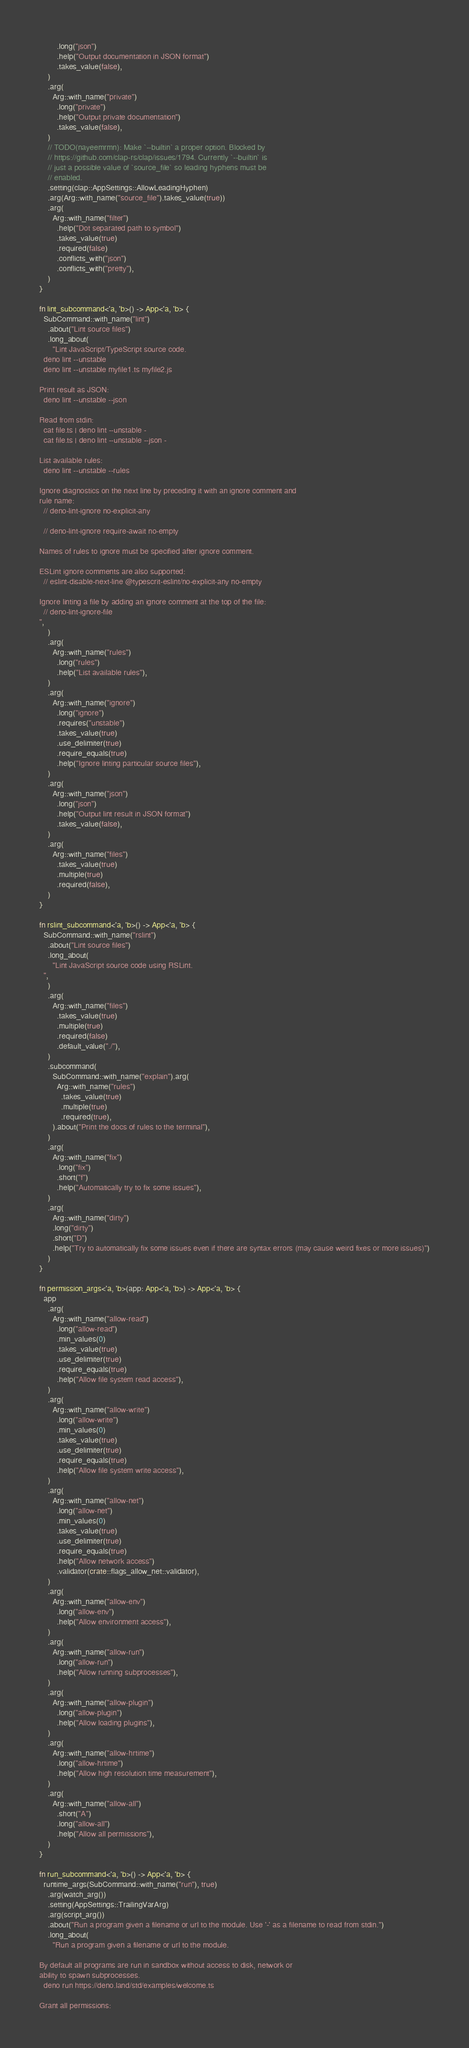<code> <loc_0><loc_0><loc_500><loc_500><_Rust_>        .long("json")
        .help("Output documentation in JSON format")
        .takes_value(false),
    )
    .arg(
      Arg::with_name("private")
        .long("private")
        .help("Output private documentation")
        .takes_value(false),
    )
    // TODO(nayeemrmn): Make `--builtin` a proper option. Blocked by
    // https://github.com/clap-rs/clap/issues/1794. Currently `--builtin` is
    // just a possible value of `source_file` so leading hyphens must be
    // enabled.
    .setting(clap::AppSettings::AllowLeadingHyphen)
    .arg(Arg::with_name("source_file").takes_value(true))
    .arg(
      Arg::with_name("filter")
        .help("Dot separated path to symbol")
        .takes_value(true)
        .required(false)
        .conflicts_with("json")
        .conflicts_with("pretty"),
    )
}

fn lint_subcommand<'a, 'b>() -> App<'a, 'b> {
  SubCommand::with_name("lint")
    .about("Lint source files")
    .long_about(
      "Lint JavaScript/TypeScript source code.
  deno lint --unstable
  deno lint --unstable myfile1.ts myfile2.js

Print result as JSON:
  deno lint --unstable --json

Read from stdin:
  cat file.ts | deno lint --unstable -
  cat file.ts | deno lint --unstable --json -

List available rules:
  deno lint --unstable --rules

Ignore diagnostics on the next line by preceding it with an ignore comment and
rule name:
  // deno-lint-ignore no-explicit-any

  // deno-lint-ignore require-await no-empty

Names of rules to ignore must be specified after ignore comment.

ESLint ignore comments are also supported:
  // eslint-disable-next-line @typescrit-eslint/no-explicit-any no-empty

Ignore linting a file by adding an ignore comment at the top of the file:
  // deno-lint-ignore-file
",
    )
    .arg(
      Arg::with_name("rules")
        .long("rules")
        .help("List available rules"),
    )
    .arg(
      Arg::with_name("ignore")
        .long("ignore")
        .requires("unstable")
        .takes_value(true)
        .use_delimiter(true)
        .require_equals(true)
        .help("Ignore linting particular source files"),
    )
    .arg(
      Arg::with_name("json")
        .long("json")
        .help("Output lint result in JSON format")
        .takes_value(false),
    )
    .arg(
      Arg::with_name("files")
        .takes_value(true)
        .multiple(true)
        .required(false),
    )
}

fn rslint_subcommand<'a, 'b>() -> App<'a, 'b> {
  SubCommand::with_name("rslint")
    .about("Lint source files")
    .long_about(
      "Lint JavaScript source code using RSLint.
  ",
    )
    .arg(
      Arg::with_name("files")
        .takes_value(true)
        .multiple(true)
        .required(false)
        .default_value("./"),
    )
    .subcommand(
      SubCommand::with_name("explain").arg(
        Arg::with_name("rules")
          .takes_value(true)
          .multiple(true)
          .required(true),
      ).about("Print the docs of rules to the terminal"),
    )
    .arg(
      Arg::with_name("fix")
        .long("fix")
        .short("f")
        .help("Automatically try to fix some issues"),
    )
    .arg(
      Arg::with_name("dirty")
      .long("dirty")
      .short("D")
      .help("Try to automatically fix some issues even if there are syntax errors (may cause weird fixes or more issues)")
    )
}

fn permission_args<'a, 'b>(app: App<'a, 'b>) -> App<'a, 'b> {
  app
    .arg(
      Arg::with_name("allow-read")
        .long("allow-read")
        .min_values(0)
        .takes_value(true)
        .use_delimiter(true)
        .require_equals(true)
        .help("Allow file system read access"),
    )
    .arg(
      Arg::with_name("allow-write")
        .long("allow-write")
        .min_values(0)
        .takes_value(true)
        .use_delimiter(true)
        .require_equals(true)
        .help("Allow file system write access"),
    )
    .arg(
      Arg::with_name("allow-net")
        .long("allow-net")
        .min_values(0)
        .takes_value(true)
        .use_delimiter(true)
        .require_equals(true)
        .help("Allow network access")
        .validator(crate::flags_allow_net::validator),
    )
    .arg(
      Arg::with_name("allow-env")
        .long("allow-env")
        .help("Allow environment access"),
    )
    .arg(
      Arg::with_name("allow-run")
        .long("allow-run")
        .help("Allow running subprocesses"),
    )
    .arg(
      Arg::with_name("allow-plugin")
        .long("allow-plugin")
        .help("Allow loading plugins"),
    )
    .arg(
      Arg::with_name("allow-hrtime")
        .long("allow-hrtime")
        .help("Allow high resolution time measurement"),
    )
    .arg(
      Arg::with_name("allow-all")
        .short("A")
        .long("allow-all")
        .help("Allow all permissions"),
    )
}

fn run_subcommand<'a, 'b>() -> App<'a, 'b> {
  runtime_args(SubCommand::with_name("run"), true)
    .arg(watch_arg())
    .setting(AppSettings::TrailingVarArg)
    .arg(script_arg())
    .about("Run a program given a filename or url to the module. Use '-' as a filename to read from stdin.")
    .long_about(
	  "Run a program given a filename or url to the module.

By default all programs are run in sandbox without access to disk, network or
ability to spawn subprocesses.
  deno run https://deno.land/std/examples/welcome.ts

Grant all permissions:</code> 